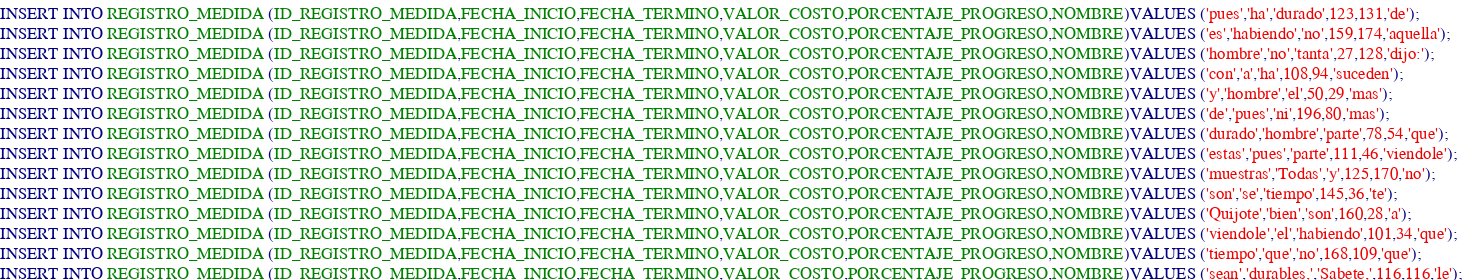Convert code to text. <code><loc_0><loc_0><loc_500><loc_500><_SQL_>INSERT INTO REGISTRO_MEDIDA (ID_REGISTRO_MEDIDA,FECHA_INICIO,FECHA_TERMINO,VALOR_COSTO,PORCENTAJE_PROGRESO,NOMBRE)VALUES ('pues','ha','durado',123,131,'de');
INSERT INTO REGISTRO_MEDIDA (ID_REGISTRO_MEDIDA,FECHA_INICIO,FECHA_TERMINO,VALOR_COSTO,PORCENTAJE_PROGRESO,NOMBRE)VALUES ('es','habiendo','no',159,174,'aquella');
INSERT INTO REGISTRO_MEDIDA (ID_REGISTRO_MEDIDA,FECHA_INICIO,FECHA_TERMINO,VALOR_COSTO,PORCENTAJE_PROGRESO,NOMBRE)VALUES ('hombre','no','tanta',27,128,'dijo:');
INSERT INTO REGISTRO_MEDIDA (ID_REGISTRO_MEDIDA,FECHA_INICIO,FECHA_TERMINO,VALOR_COSTO,PORCENTAJE_PROGRESO,NOMBRE)VALUES ('con','a','ha',108,94,'suceden');
INSERT INTO REGISTRO_MEDIDA (ID_REGISTRO_MEDIDA,FECHA_INICIO,FECHA_TERMINO,VALOR_COSTO,PORCENTAJE_PROGRESO,NOMBRE)VALUES ('y','hombre','el',50,29,'mas');
INSERT INTO REGISTRO_MEDIDA (ID_REGISTRO_MEDIDA,FECHA_INICIO,FECHA_TERMINO,VALOR_COSTO,PORCENTAJE_PROGRESO,NOMBRE)VALUES ('de','pues','ni',196,80,'mas');
INSERT INTO REGISTRO_MEDIDA (ID_REGISTRO_MEDIDA,FECHA_INICIO,FECHA_TERMINO,VALOR_COSTO,PORCENTAJE_PROGRESO,NOMBRE)VALUES ('durado','hombre','parte',78,54,'que');
INSERT INTO REGISTRO_MEDIDA (ID_REGISTRO_MEDIDA,FECHA_INICIO,FECHA_TERMINO,VALOR_COSTO,PORCENTAJE_PROGRESO,NOMBRE)VALUES ('estas','pues','parte',111,46,'viendole');
INSERT INTO REGISTRO_MEDIDA (ID_REGISTRO_MEDIDA,FECHA_INICIO,FECHA_TERMINO,VALOR_COSTO,PORCENTAJE_PROGRESO,NOMBRE)VALUES ('muestras','Todas','y',125,170,'no');
INSERT INTO REGISTRO_MEDIDA (ID_REGISTRO_MEDIDA,FECHA_INICIO,FECHA_TERMINO,VALOR_COSTO,PORCENTAJE_PROGRESO,NOMBRE)VALUES ('son','se','tiempo',145,36,'te');
INSERT INTO REGISTRO_MEDIDA (ID_REGISTRO_MEDIDA,FECHA_INICIO,FECHA_TERMINO,VALOR_COSTO,PORCENTAJE_PROGRESO,NOMBRE)VALUES ('Quijote','bien','son',160,28,'a');
INSERT INTO REGISTRO_MEDIDA (ID_REGISTRO_MEDIDA,FECHA_INICIO,FECHA_TERMINO,VALOR_COSTO,PORCENTAJE_PROGRESO,NOMBRE)VALUES ('viendole','el','habiendo',101,34,'que');
INSERT INTO REGISTRO_MEDIDA (ID_REGISTRO_MEDIDA,FECHA_INICIO,FECHA_TERMINO,VALOR_COSTO,PORCENTAJE_PROGRESO,NOMBRE)VALUES ('tiempo','que','no',168,109,'que');
INSERT INTO REGISTRO_MEDIDA (ID_REGISTRO_MEDIDA,FECHA_INICIO,FECHA_TERMINO,VALOR_COSTO,PORCENTAJE_PROGRESO,NOMBRE)VALUES ('sean','durables,','Sabete,',116,116,'le');</code> 